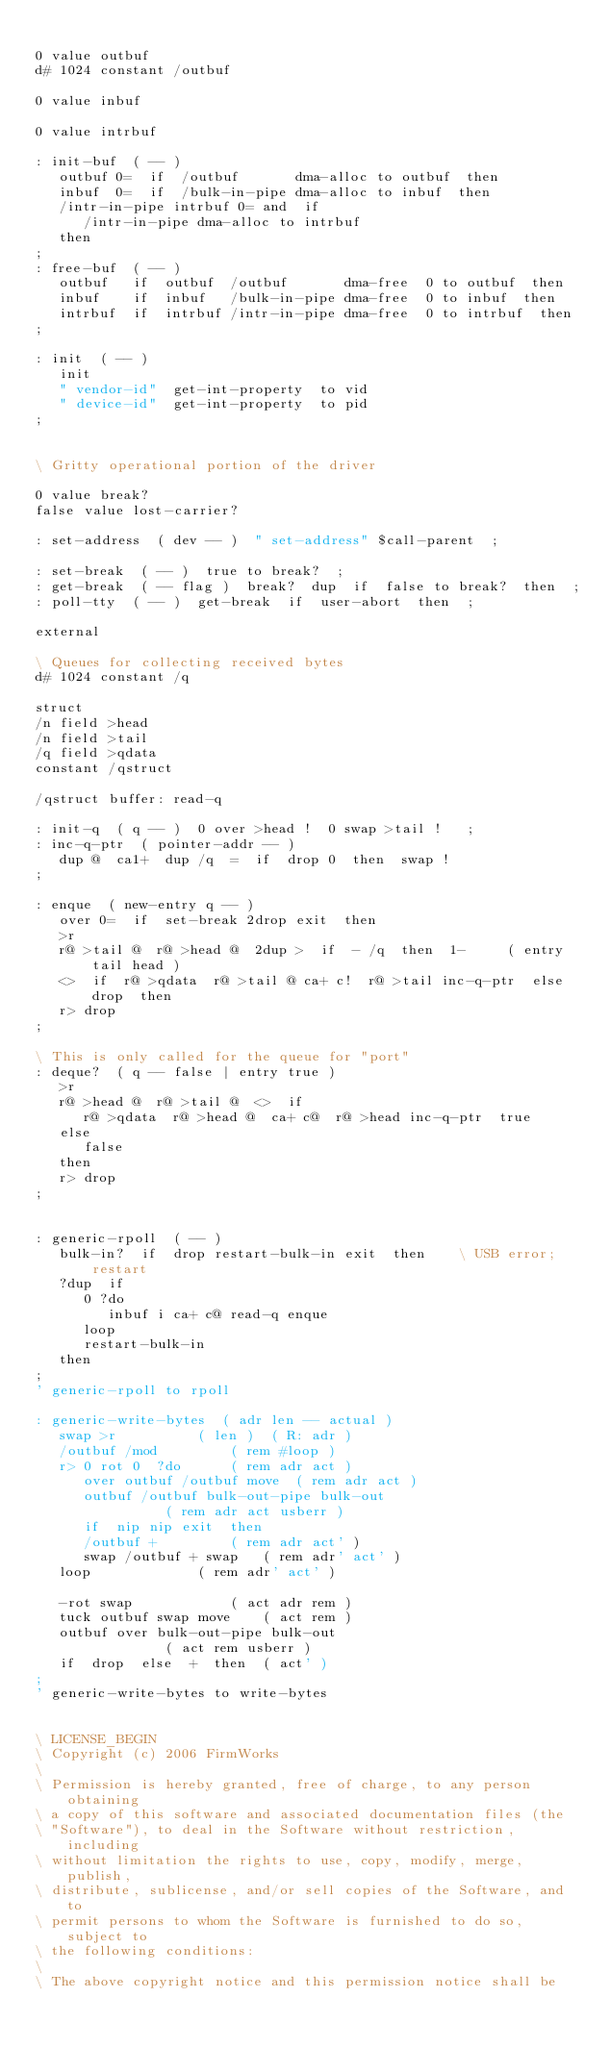<code> <loc_0><loc_0><loc_500><loc_500><_Forth_>
0 value outbuf
d# 1024 constant /outbuf

0 value inbuf

0 value intrbuf

: init-buf  ( -- )
   outbuf 0=  if  /outbuf       dma-alloc to outbuf  then
   inbuf  0=  if  /bulk-in-pipe dma-alloc to inbuf  then
   /intr-in-pipe intrbuf 0= and  if
      /intr-in-pipe dma-alloc to intrbuf
   then
;
: free-buf  ( -- )
   outbuf   if  outbuf  /outbuf       dma-free  0 to outbuf  then
   inbuf    if  inbuf   /bulk-in-pipe dma-free  0 to inbuf  then
   intrbuf  if  intrbuf /intr-in-pipe dma-free  0 to intrbuf  then
;

: init  ( -- )
   init
   " vendor-id"  get-int-property  to vid
   " device-id"  get-int-property  to pid
;


\ Gritty operational portion of the driver

0 value break?
false value lost-carrier?

: set-address  ( dev -- )  " set-address" $call-parent  ;

: set-break  ( -- )  true to break?  ;
: get-break  ( -- flag )  break?  dup  if  false to break?  then  ;
: poll-tty  ( -- )  get-break  if  user-abort  then  ;

external

\ Queues for collecting received bytes
d# 1024 constant /q

struct
/n field >head
/n field >tail
/q field >qdata
constant /qstruct

/qstruct buffer: read-q

: init-q  ( q -- )  0 over >head !  0 swap >tail !   ;
: inc-q-ptr  ( pointer-addr -- )
   dup @  ca1+  dup /q  =  if  drop 0  then  swap !
;

: enque  ( new-entry q -- )
   over 0=  if  set-break 2drop exit  then
   >r
   r@ >tail @  r@ >head @  2dup >  if  - /q  then  1-     ( entry tail head )
   <>  if  r@ >qdata  r@ >tail @ ca+ c!  r@ >tail inc-q-ptr  else  drop  then
   r> drop
;

\ This is only called for the queue for "port"
: deque?  ( q -- false | entry true )
   >r
   r@ >head @  r@ >tail @  <>  if
      r@ >qdata  r@ >head @  ca+ c@  r@ >head inc-q-ptr  true
   else
      false
   then
   r> drop
;


: generic-rpoll  ( -- )
   bulk-in?  if  drop restart-bulk-in exit  then	\ USB error; restart
   ?dup  if
      0 ?do
         inbuf i ca+ c@ read-q enque
      loop
      restart-bulk-in
   then
;
' generic-rpoll to rpoll

: generic-write-bytes  ( adr len -- actual )
   swap >r			( len )  ( R: adr )
   /outbuf /mod			( rem #loop )
   r> 0 rot 0  ?do		( rem adr act )
      over outbuf /outbuf move	( rem adr act )
      outbuf /outbuf bulk-out-pipe bulk-out
				( rem adr act usberr )
      if  nip nip exit  then
      /outbuf +			( rem adr act' )
      swap /outbuf + swap	( rem adr' act' )
   loop				( rem adr' act' ) 

   -rot swap			( act adr rem )
   tuck outbuf swap move	( act rem )
   outbuf over bulk-out-pipe bulk-out
				( act rem usberr )
   if  drop  else  +  then	( act' )
;
' generic-write-bytes to write-bytes


\ LICENSE_BEGIN
\ Copyright (c) 2006 FirmWorks
\ 
\ Permission is hereby granted, free of charge, to any person obtaining
\ a copy of this software and associated documentation files (the
\ "Software"), to deal in the Software without restriction, including
\ without limitation the rights to use, copy, modify, merge, publish,
\ distribute, sublicense, and/or sell copies of the Software, and to
\ permit persons to whom the Software is furnished to do so, subject to
\ the following conditions:
\ 
\ The above copyright notice and this permission notice shall be</code> 